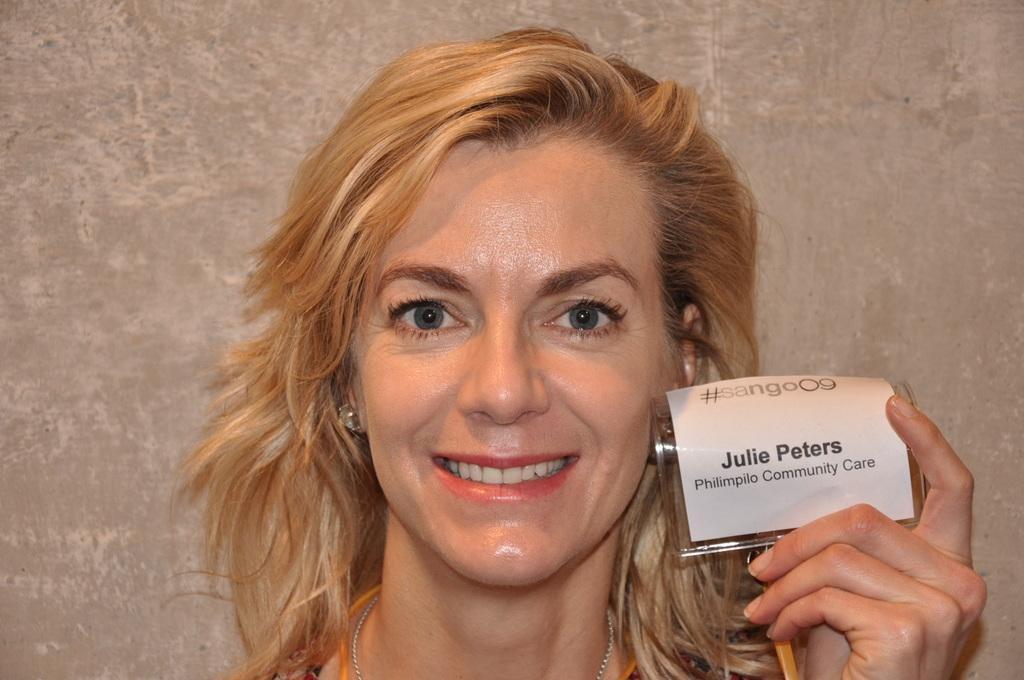Could you give a brief overview of what you see in this image? In this picture, we see a woman is smiling and she might be posing for the photo. She is holding a small glass board and a label with some text printed on it. In the background, it is grey in color and it might be a wall. 